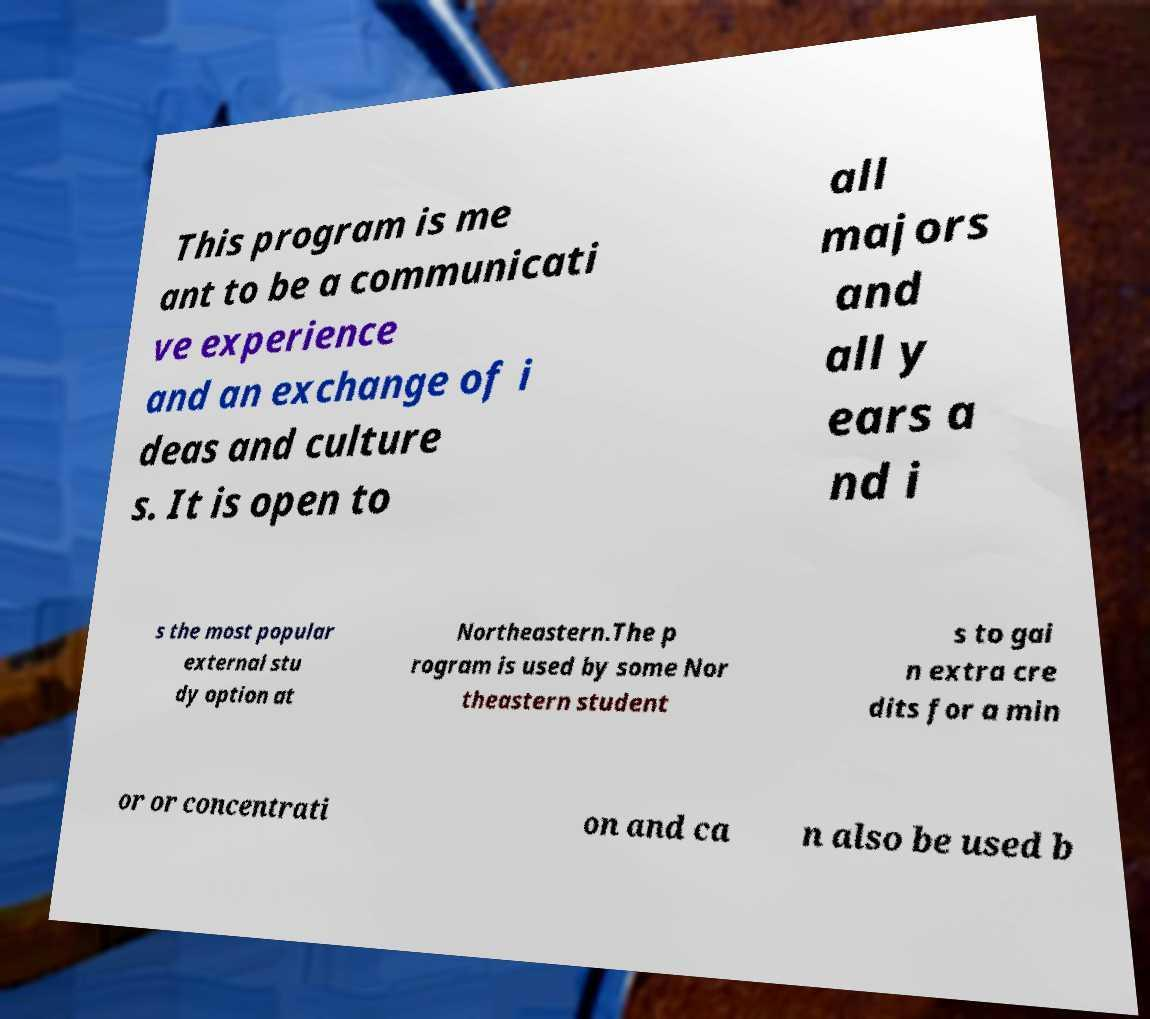What messages or text are displayed in this image? I need them in a readable, typed format. This program is me ant to be a communicati ve experience and an exchange of i deas and culture s. It is open to all majors and all y ears a nd i s the most popular external stu dy option at Northeastern.The p rogram is used by some Nor theastern student s to gai n extra cre dits for a min or or concentrati on and ca n also be used b 